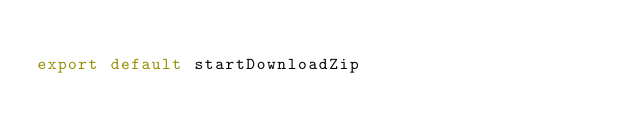<code> <loc_0><loc_0><loc_500><loc_500><_TypeScript_>
export default startDownloadZip
</code> 